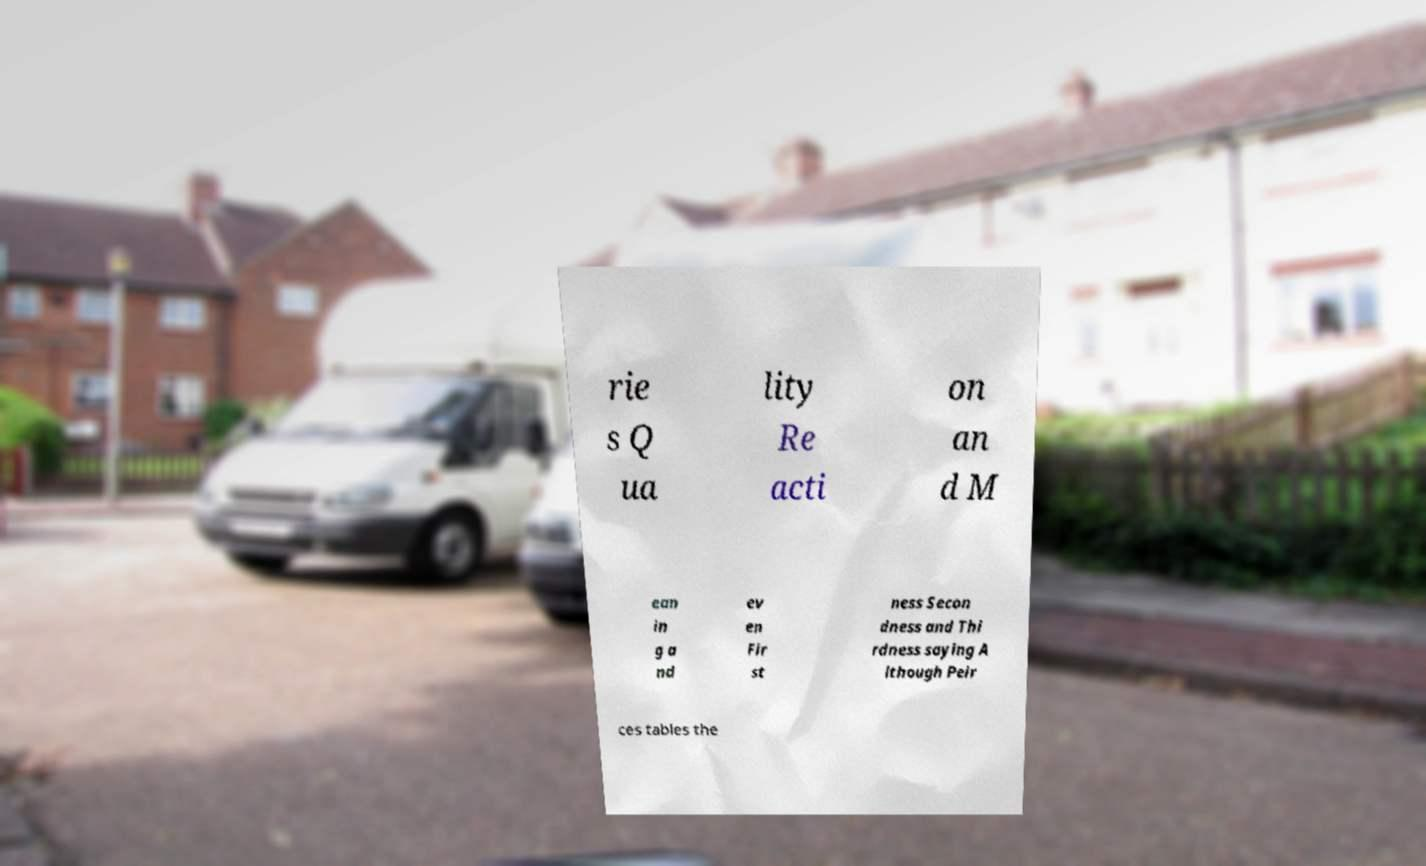Please identify and transcribe the text found in this image. rie s Q ua lity Re acti on an d M ean in g a nd ev en Fir st ness Secon dness and Thi rdness saying A lthough Peir ces tables the 